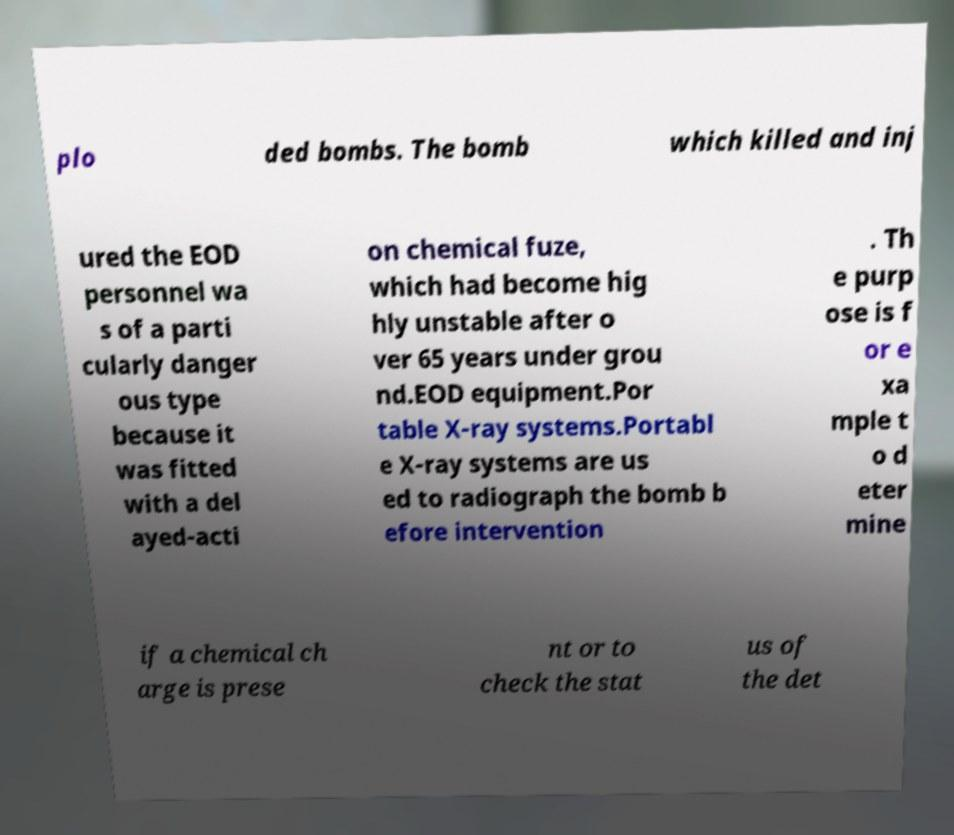I need the written content from this picture converted into text. Can you do that? plo ded bombs. The bomb which killed and inj ured the EOD personnel wa s of a parti cularly danger ous type because it was fitted with a del ayed-acti on chemical fuze, which had become hig hly unstable after o ver 65 years under grou nd.EOD equipment.Por table X-ray systems.Portabl e X-ray systems are us ed to radiograph the bomb b efore intervention . Th e purp ose is f or e xa mple t o d eter mine if a chemical ch arge is prese nt or to check the stat us of the det 